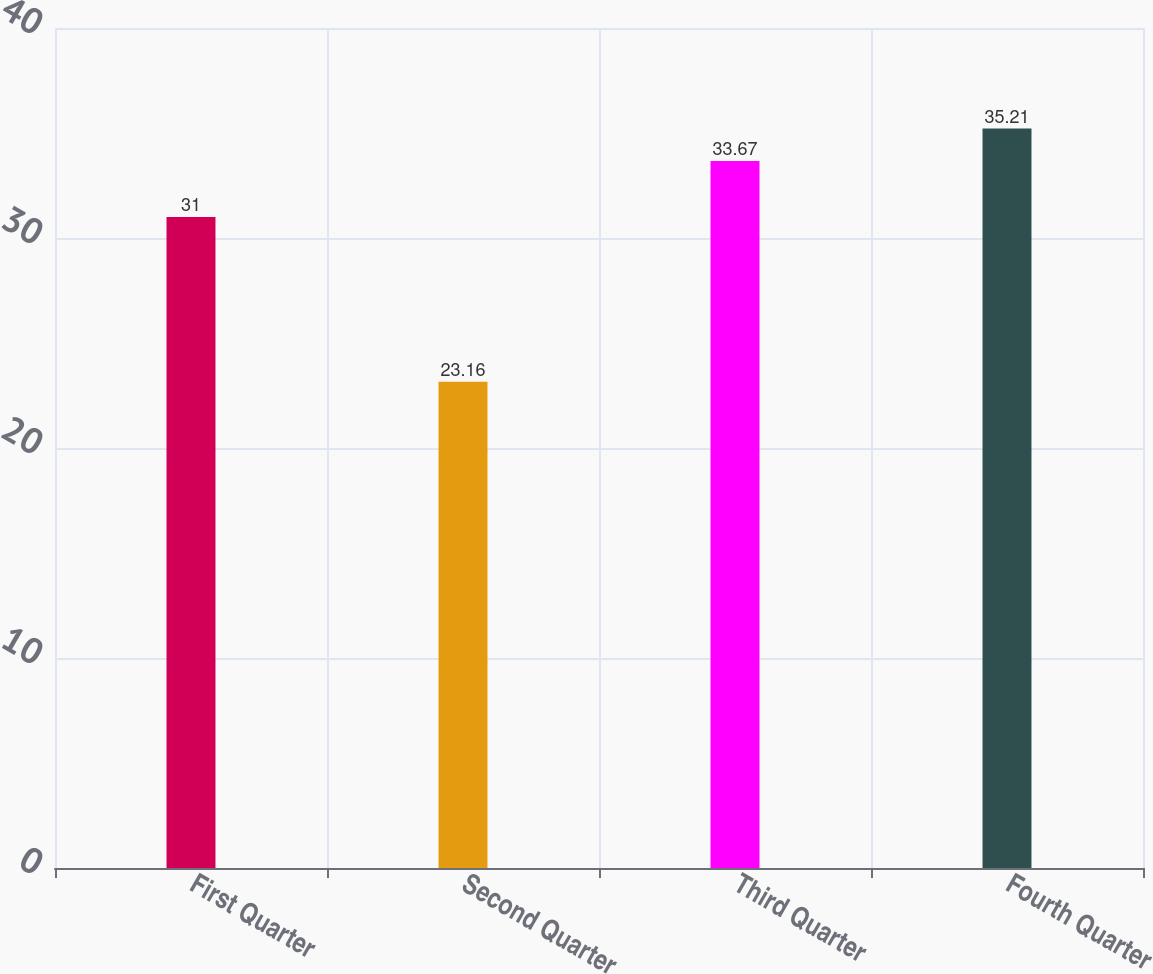Convert chart to OTSL. <chart><loc_0><loc_0><loc_500><loc_500><bar_chart><fcel>First Quarter<fcel>Second Quarter<fcel>Third Quarter<fcel>Fourth Quarter<nl><fcel>31<fcel>23.16<fcel>33.67<fcel>35.21<nl></chart> 